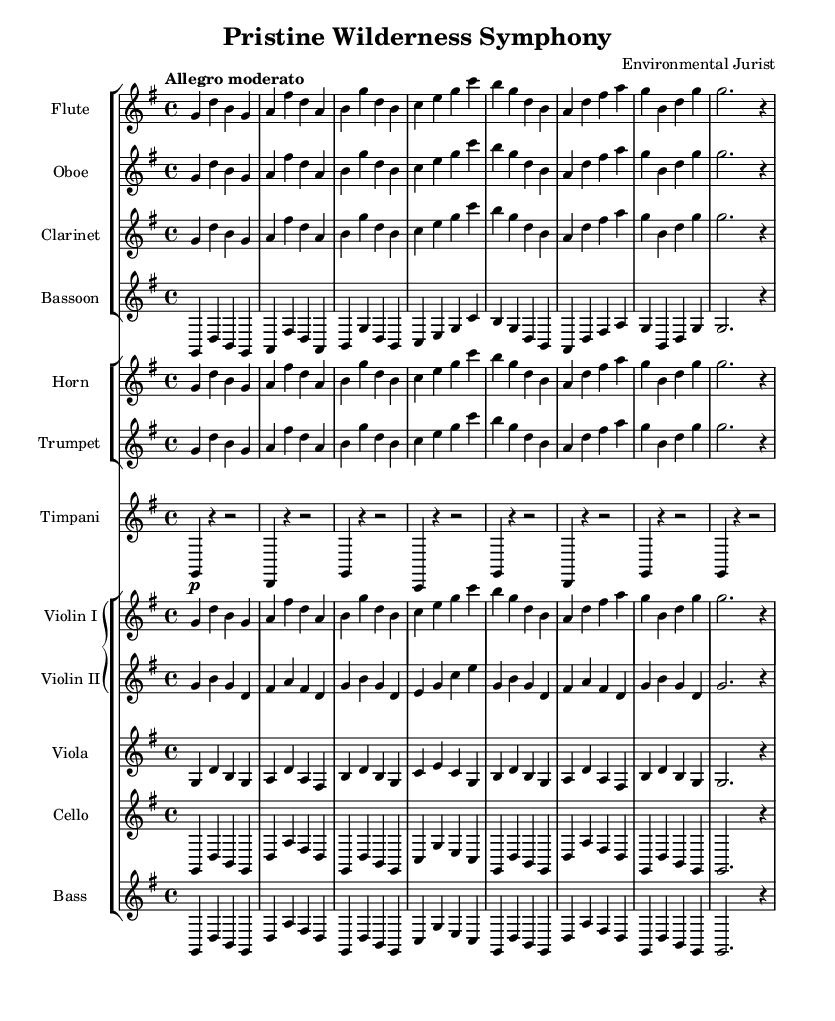What is the key signature of this music? The key signature is G major, indicated by one sharp (F#) in the staff.
Answer: G major What is the time signature of this music? The time signature appears as 4/4, meaning there are four beats per measure.
Answer: 4/4 What is the indicated tempo for this piece? The tempo marking "Allegro moderato" suggests a moderate and lively pace, typical for this style.
Answer: Allegro moderato How many instruments are present in this symphony? The score contains a total of 13 instrumental parts, including woodwinds, brass, timpani, and strings.
Answer: 13 Which instrument plays the lowest part in this score? The bass plays the lowest part, providing the foundation for the harmonic structure in the symphony.
Answer: Bass How many measures are present in the flute part? Counting the measures in the flute part shows there are a total of 8 measures.
Answer: 8 Which section features the violins, and how are they grouped? The violins are grouped in a GrandStaff, indicating they function together to produce harmony and melody across two staves.
Answer: GrandStaff 